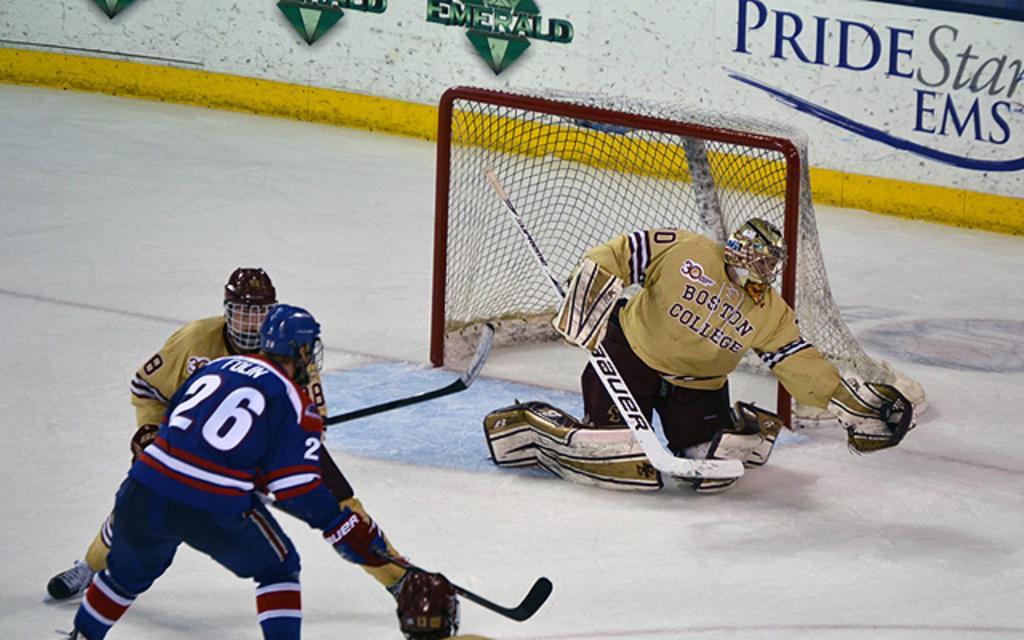Could you give a brief overview of what you see in this image? There are people in the foreground area of the image, it seems like they are playing hockey, there is a net and a wall in the background. 